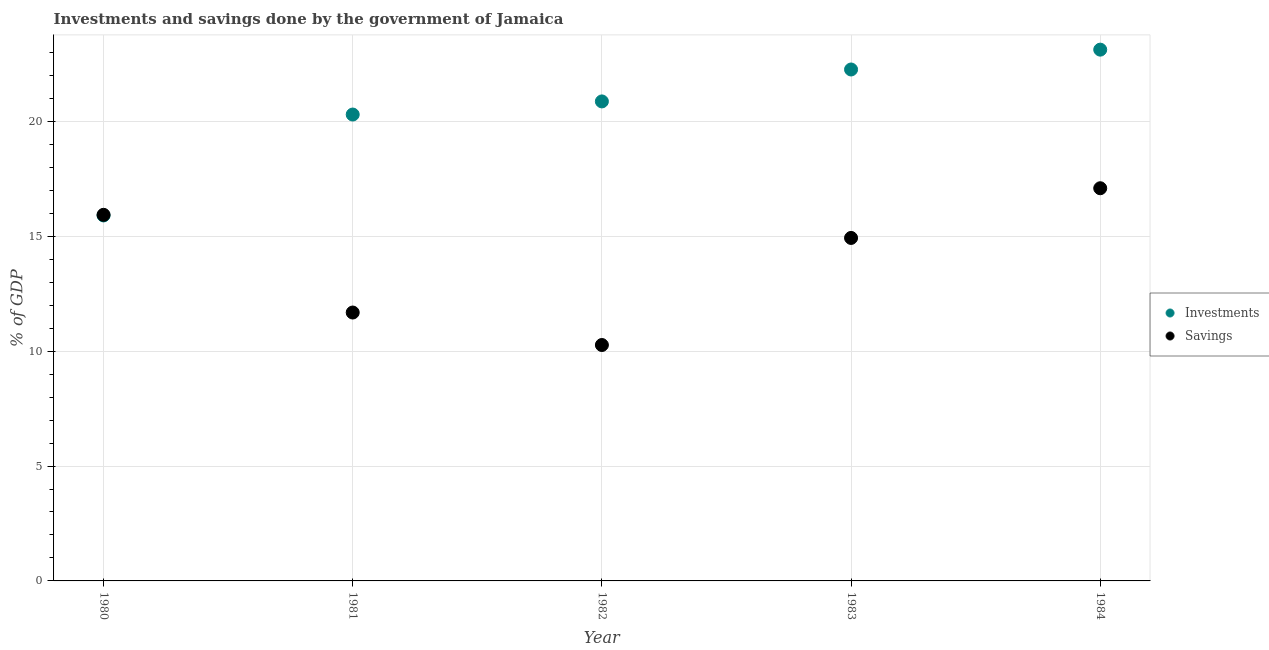Is the number of dotlines equal to the number of legend labels?
Offer a terse response. Yes. What is the investments of government in 1984?
Ensure brevity in your answer.  23.12. Across all years, what is the maximum savings of government?
Provide a succinct answer. 17.09. Across all years, what is the minimum savings of government?
Your answer should be compact. 10.27. In which year was the savings of government maximum?
Your answer should be very brief. 1984. In which year was the savings of government minimum?
Provide a short and direct response. 1982. What is the total savings of government in the graph?
Keep it short and to the point. 69.9. What is the difference between the investments of government in 1980 and that in 1982?
Ensure brevity in your answer.  -4.96. What is the difference between the savings of government in 1982 and the investments of government in 1981?
Ensure brevity in your answer.  -10.03. What is the average savings of government per year?
Your response must be concise. 13.98. In the year 1984, what is the difference between the investments of government and savings of government?
Provide a succinct answer. 6.03. In how many years, is the savings of government greater than 3 %?
Your answer should be very brief. 5. What is the ratio of the savings of government in 1982 to that in 1984?
Provide a short and direct response. 0.6. Is the difference between the savings of government in 1980 and 1982 greater than the difference between the investments of government in 1980 and 1982?
Make the answer very short. Yes. What is the difference between the highest and the second highest investments of government?
Provide a short and direct response. 0.86. What is the difference between the highest and the lowest savings of government?
Offer a terse response. 6.82. Is the sum of the investments of government in 1980 and 1982 greater than the maximum savings of government across all years?
Provide a succinct answer. Yes. Does the investments of government monotonically increase over the years?
Give a very brief answer. Yes. How many years are there in the graph?
Your response must be concise. 5. What is the difference between two consecutive major ticks on the Y-axis?
Provide a short and direct response. 5. Does the graph contain grids?
Keep it short and to the point. Yes. Where does the legend appear in the graph?
Provide a succinct answer. Center right. How many legend labels are there?
Make the answer very short. 2. What is the title of the graph?
Make the answer very short. Investments and savings done by the government of Jamaica. What is the label or title of the X-axis?
Your response must be concise. Year. What is the label or title of the Y-axis?
Your response must be concise. % of GDP. What is the % of GDP of Investments in 1980?
Offer a terse response. 15.91. What is the % of GDP in Savings in 1980?
Keep it short and to the point. 15.93. What is the % of GDP in Investments in 1981?
Give a very brief answer. 20.3. What is the % of GDP of Savings in 1981?
Your answer should be very brief. 11.68. What is the % of GDP of Investments in 1982?
Provide a succinct answer. 20.87. What is the % of GDP in Savings in 1982?
Your response must be concise. 10.27. What is the % of GDP in Investments in 1983?
Provide a succinct answer. 22.26. What is the % of GDP of Savings in 1983?
Your response must be concise. 14.93. What is the % of GDP of Investments in 1984?
Keep it short and to the point. 23.12. What is the % of GDP of Savings in 1984?
Offer a terse response. 17.09. Across all years, what is the maximum % of GDP in Investments?
Provide a short and direct response. 23.12. Across all years, what is the maximum % of GDP of Savings?
Offer a terse response. 17.09. Across all years, what is the minimum % of GDP in Investments?
Your answer should be compact. 15.91. Across all years, what is the minimum % of GDP in Savings?
Ensure brevity in your answer.  10.27. What is the total % of GDP of Investments in the graph?
Keep it short and to the point. 102.45. What is the total % of GDP in Savings in the graph?
Your answer should be very brief. 69.9. What is the difference between the % of GDP of Investments in 1980 and that in 1981?
Give a very brief answer. -4.39. What is the difference between the % of GDP of Savings in 1980 and that in 1981?
Your response must be concise. 4.25. What is the difference between the % of GDP of Investments in 1980 and that in 1982?
Provide a short and direct response. -4.96. What is the difference between the % of GDP of Savings in 1980 and that in 1982?
Give a very brief answer. 5.67. What is the difference between the % of GDP of Investments in 1980 and that in 1983?
Make the answer very short. -6.35. What is the difference between the % of GDP in Savings in 1980 and that in 1983?
Your answer should be very brief. 1.01. What is the difference between the % of GDP in Investments in 1980 and that in 1984?
Your response must be concise. -7.22. What is the difference between the % of GDP of Savings in 1980 and that in 1984?
Your answer should be very brief. -1.16. What is the difference between the % of GDP in Investments in 1981 and that in 1982?
Offer a very short reply. -0.57. What is the difference between the % of GDP of Savings in 1981 and that in 1982?
Ensure brevity in your answer.  1.41. What is the difference between the % of GDP in Investments in 1981 and that in 1983?
Give a very brief answer. -1.96. What is the difference between the % of GDP of Savings in 1981 and that in 1983?
Make the answer very short. -3.25. What is the difference between the % of GDP in Investments in 1981 and that in 1984?
Keep it short and to the point. -2.82. What is the difference between the % of GDP in Savings in 1981 and that in 1984?
Provide a succinct answer. -5.41. What is the difference between the % of GDP in Investments in 1982 and that in 1983?
Make the answer very short. -1.39. What is the difference between the % of GDP in Savings in 1982 and that in 1983?
Your answer should be very brief. -4.66. What is the difference between the % of GDP of Investments in 1982 and that in 1984?
Provide a short and direct response. -2.25. What is the difference between the % of GDP in Savings in 1982 and that in 1984?
Your response must be concise. -6.82. What is the difference between the % of GDP in Investments in 1983 and that in 1984?
Your response must be concise. -0.86. What is the difference between the % of GDP of Savings in 1983 and that in 1984?
Provide a succinct answer. -2.16. What is the difference between the % of GDP of Investments in 1980 and the % of GDP of Savings in 1981?
Keep it short and to the point. 4.22. What is the difference between the % of GDP in Investments in 1980 and the % of GDP in Savings in 1982?
Your answer should be compact. 5.64. What is the difference between the % of GDP in Investments in 1980 and the % of GDP in Savings in 1983?
Make the answer very short. 0.98. What is the difference between the % of GDP in Investments in 1980 and the % of GDP in Savings in 1984?
Offer a very short reply. -1.18. What is the difference between the % of GDP in Investments in 1981 and the % of GDP in Savings in 1982?
Make the answer very short. 10.03. What is the difference between the % of GDP in Investments in 1981 and the % of GDP in Savings in 1983?
Keep it short and to the point. 5.37. What is the difference between the % of GDP of Investments in 1981 and the % of GDP of Savings in 1984?
Provide a succinct answer. 3.21. What is the difference between the % of GDP in Investments in 1982 and the % of GDP in Savings in 1983?
Provide a short and direct response. 5.94. What is the difference between the % of GDP in Investments in 1982 and the % of GDP in Savings in 1984?
Your answer should be compact. 3.78. What is the difference between the % of GDP in Investments in 1983 and the % of GDP in Savings in 1984?
Your response must be concise. 5.17. What is the average % of GDP of Investments per year?
Your answer should be very brief. 20.49. What is the average % of GDP of Savings per year?
Your answer should be very brief. 13.98. In the year 1980, what is the difference between the % of GDP in Investments and % of GDP in Savings?
Your answer should be compact. -0.03. In the year 1981, what is the difference between the % of GDP in Investments and % of GDP in Savings?
Ensure brevity in your answer.  8.62. In the year 1982, what is the difference between the % of GDP in Investments and % of GDP in Savings?
Your response must be concise. 10.6. In the year 1983, what is the difference between the % of GDP of Investments and % of GDP of Savings?
Make the answer very short. 7.33. In the year 1984, what is the difference between the % of GDP in Investments and % of GDP in Savings?
Make the answer very short. 6.03. What is the ratio of the % of GDP in Investments in 1980 to that in 1981?
Ensure brevity in your answer.  0.78. What is the ratio of the % of GDP in Savings in 1980 to that in 1981?
Provide a short and direct response. 1.36. What is the ratio of the % of GDP of Investments in 1980 to that in 1982?
Provide a short and direct response. 0.76. What is the ratio of the % of GDP in Savings in 1980 to that in 1982?
Make the answer very short. 1.55. What is the ratio of the % of GDP in Investments in 1980 to that in 1983?
Your answer should be compact. 0.71. What is the ratio of the % of GDP in Savings in 1980 to that in 1983?
Provide a short and direct response. 1.07. What is the ratio of the % of GDP in Investments in 1980 to that in 1984?
Keep it short and to the point. 0.69. What is the ratio of the % of GDP in Savings in 1980 to that in 1984?
Offer a very short reply. 0.93. What is the ratio of the % of GDP of Investments in 1981 to that in 1982?
Make the answer very short. 0.97. What is the ratio of the % of GDP in Savings in 1981 to that in 1982?
Ensure brevity in your answer.  1.14. What is the ratio of the % of GDP of Investments in 1981 to that in 1983?
Your response must be concise. 0.91. What is the ratio of the % of GDP of Savings in 1981 to that in 1983?
Give a very brief answer. 0.78. What is the ratio of the % of GDP in Investments in 1981 to that in 1984?
Provide a succinct answer. 0.88. What is the ratio of the % of GDP in Savings in 1981 to that in 1984?
Your answer should be compact. 0.68. What is the ratio of the % of GDP in Investments in 1982 to that in 1983?
Your answer should be compact. 0.94. What is the ratio of the % of GDP in Savings in 1982 to that in 1983?
Make the answer very short. 0.69. What is the ratio of the % of GDP of Investments in 1982 to that in 1984?
Provide a short and direct response. 0.9. What is the ratio of the % of GDP in Savings in 1982 to that in 1984?
Ensure brevity in your answer.  0.6. What is the ratio of the % of GDP of Investments in 1983 to that in 1984?
Your response must be concise. 0.96. What is the ratio of the % of GDP in Savings in 1983 to that in 1984?
Give a very brief answer. 0.87. What is the difference between the highest and the second highest % of GDP of Investments?
Your answer should be very brief. 0.86. What is the difference between the highest and the second highest % of GDP in Savings?
Your answer should be compact. 1.16. What is the difference between the highest and the lowest % of GDP in Investments?
Give a very brief answer. 7.22. What is the difference between the highest and the lowest % of GDP of Savings?
Provide a short and direct response. 6.82. 